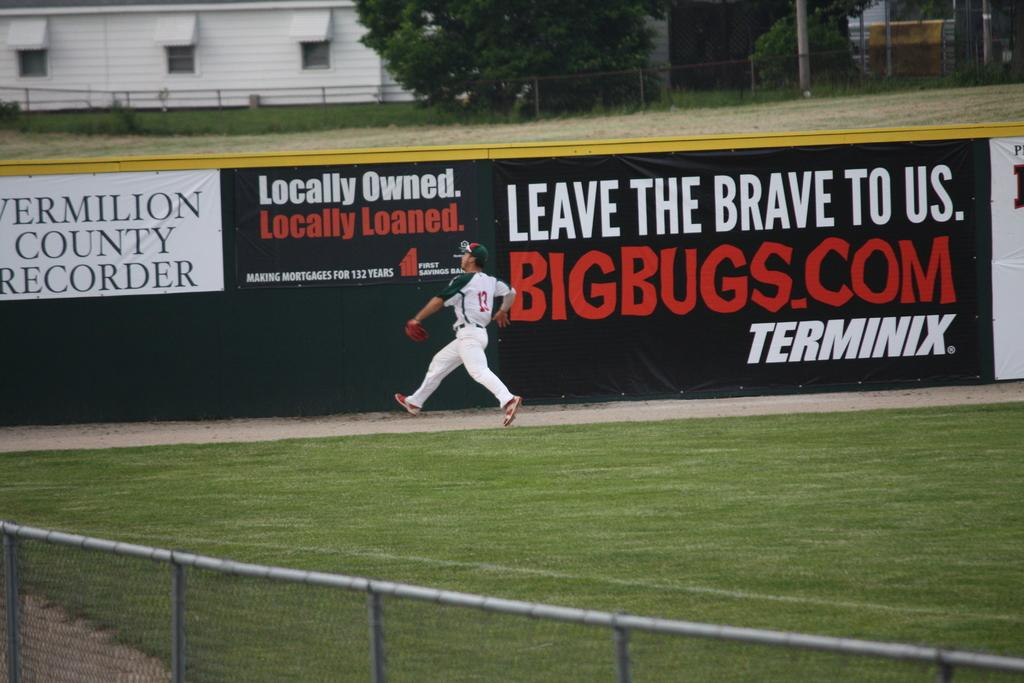<image>
Share a concise interpretation of the image provided. Ball player infront of a sign that reads BigBugs.COM in red letters. 